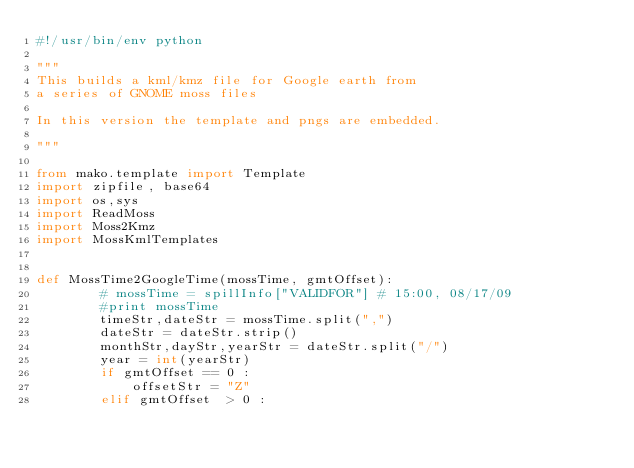Convert code to text. <code><loc_0><loc_0><loc_500><loc_500><_Python_>#!/usr/bin/env python

"""
This builds a kml/kmz file for Google earth from
a series of GNOME moss files

In this version the template and pngs are embedded.

"""

from mako.template import Template
import zipfile, base64
import os,sys
import ReadMoss
import Moss2Kmz
import MossKmlTemplates


def MossTime2GoogleTime(mossTime, gmtOffset):
        # mossTime = spillInfo["VALIDFOR"] # 15:00, 08/17/09
        #print mossTime
        timeStr,dateStr = mossTime.split(",")
        dateStr = dateStr.strip()
        monthStr,dayStr,yearStr = dateStr.split("/")
        year = int(yearStr)
        if gmtOffset == 0 :
            offsetStr = "Z"
        elif gmtOffset  > 0 :</code> 